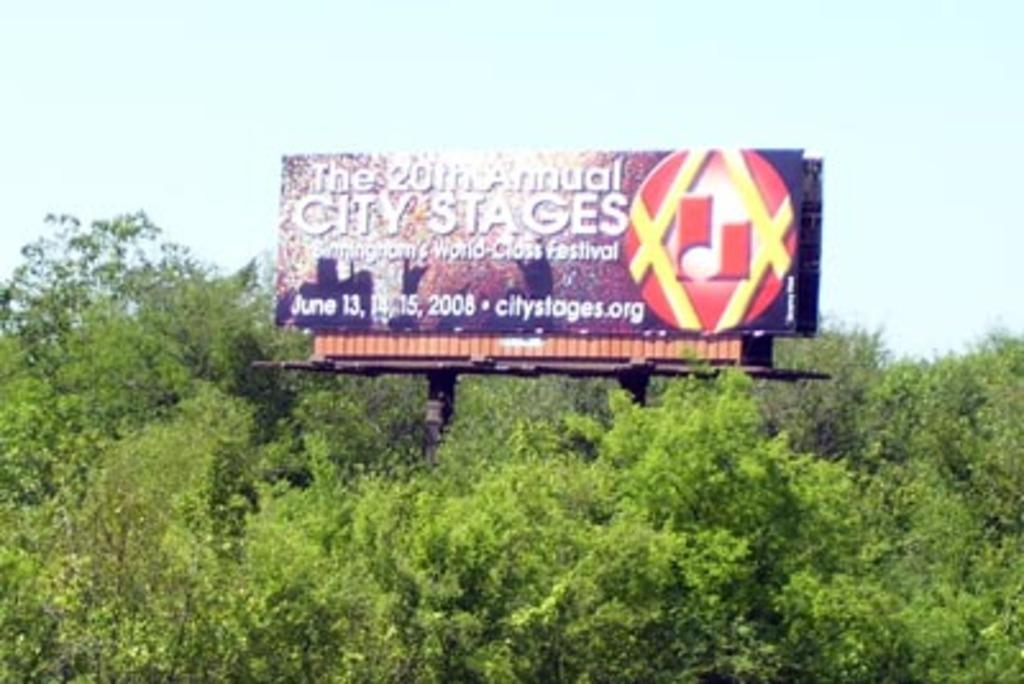<image>
Create a compact narrative representing the image presented. Billboard high above the trees for the 20th annual city stages. 